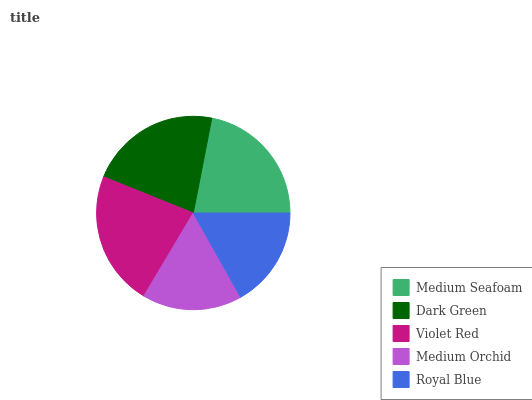Is Medium Orchid the minimum?
Answer yes or no. Yes. Is Violet Red the maximum?
Answer yes or no. Yes. Is Dark Green the minimum?
Answer yes or no. No. Is Dark Green the maximum?
Answer yes or no. No. Is Dark Green greater than Medium Seafoam?
Answer yes or no. Yes. Is Medium Seafoam less than Dark Green?
Answer yes or no. Yes. Is Medium Seafoam greater than Dark Green?
Answer yes or no. No. Is Dark Green less than Medium Seafoam?
Answer yes or no. No. Is Medium Seafoam the high median?
Answer yes or no. Yes. Is Medium Seafoam the low median?
Answer yes or no. Yes. Is Violet Red the high median?
Answer yes or no. No. Is Medium Orchid the low median?
Answer yes or no. No. 